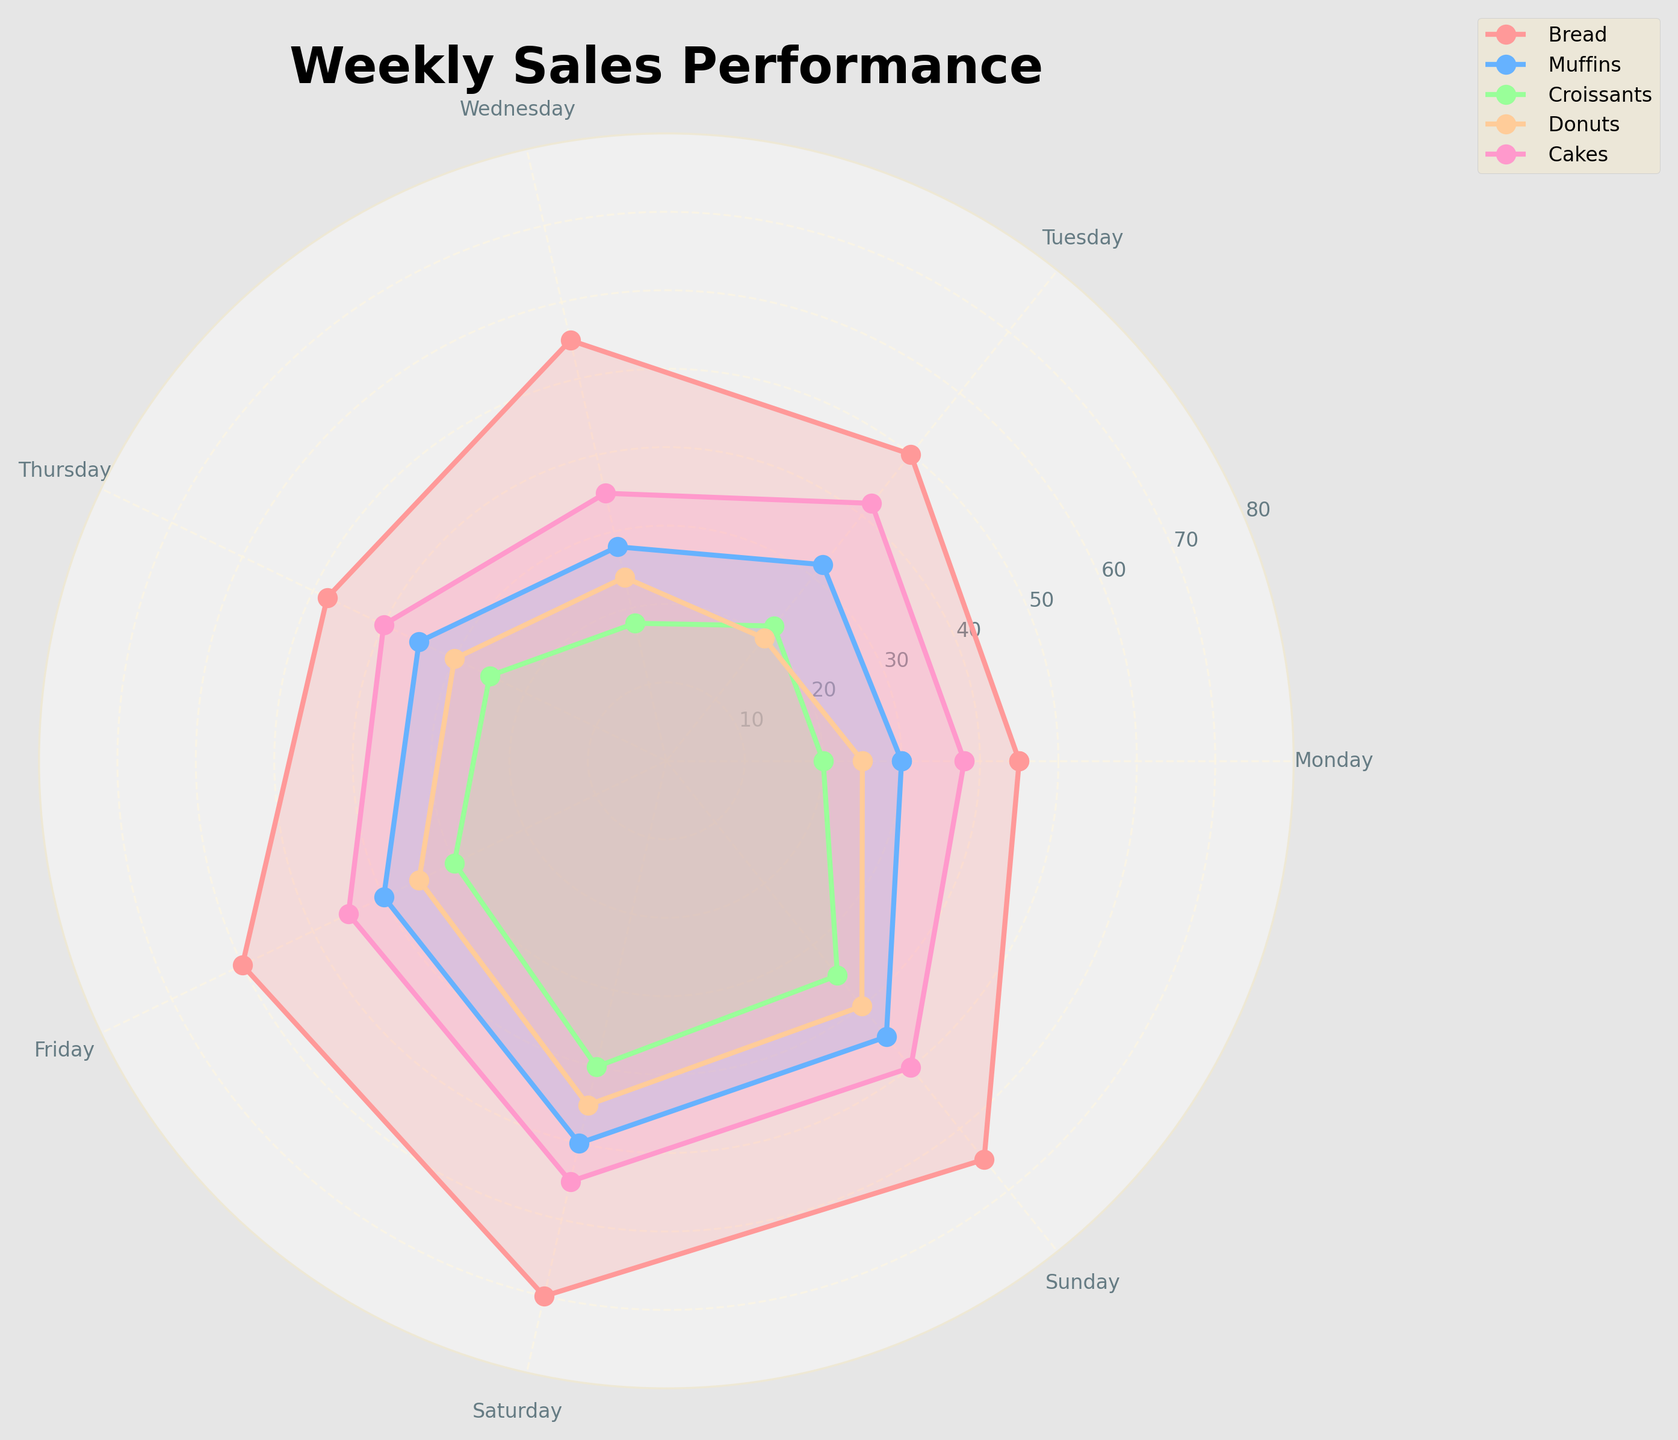What's the title of the chart? The title is written at the top of the chart and summarizes the data being displayed. It reads "Weekly Sales Performance".
Answer: Weekly Sales Performance What are the bakery items tracked in the radar chart? The legend located at the upper right of the chart lists five bakery items, which are Bread, Muffins, Croissants, Donuts, and Cakes.
Answer: Bread, Muffins, Croissants, Donuts, Cakes Which day has the highest sales for Bread? By looking at the topmost value for the Bread plot, Bread's highest sales, represented by the longest line for Bread, occur on Saturday.
Answer: Saturday Compare the sales of Muffins and Donuts on Thursday. Which one is higher? On Thursday, Muffins have a value of 35 and Donuts have a value of 30. Muffins surpass Donuts on this day.
Answer: Muffins What's the average sales of Cakes over the week? To find the average, sum up the sales of Cakes for all days (38 + 42 + 35 + 40 + 45 + 55 + 50 = 305) and then divide by the number of days (7). The average is 305/7.
Answer: 43.57 On which day are Croissants' sales the lowest? By tracing the shortest spoke for Croissants, we find that their sales are lowest on Wednesday, where the value is smallest.
Answer: Wednesday Which bakery item has the most consistent sales figures throughout the week? Consistent sales figures mean the line plot for the item remains relatively stable without dramatic peaks or valleys. The sales for Cakes appear to be the most stable.
Answer: Cakes What is the combined sales figure for Donuts on Friday and Saturday? Adding the sales figures for Donuts on Friday (35) and Saturday (45) gives a total of 35 + 45.
Answer: 80 Comparing Bread and Cakes, which bakery item increased the most in sales from Monday to Saturday? Bread sales increased from 45 on Monday to 70 on Saturday, a difference of 70 - 45. Cakes sales increased from 38 on Monday to 55 on Saturday, a difference of 55 - 38. Bread's increase (25) is greater than that of Cakes (17).
Answer: Bread 